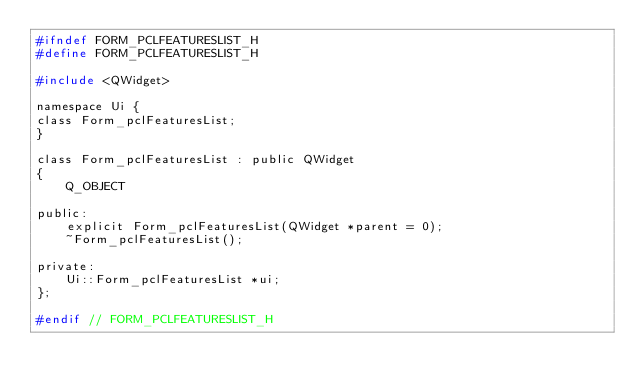<code> <loc_0><loc_0><loc_500><loc_500><_C_>#ifndef FORM_PCLFEATURESLIST_H
#define FORM_PCLFEATURESLIST_H

#include <QWidget>

namespace Ui {
class Form_pclFeaturesList;
}

class Form_pclFeaturesList : public QWidget
{
    Q_OBJECT

public:
    explicit Form_pclFeaturesList(QWidget *parent = 0);
    ~Form_pclFeaturesList();

private:
    Ui::Form_pclFeaturesList *ui;
};

#endif // FORM_PCLFEATURESLIST_H
</code> 